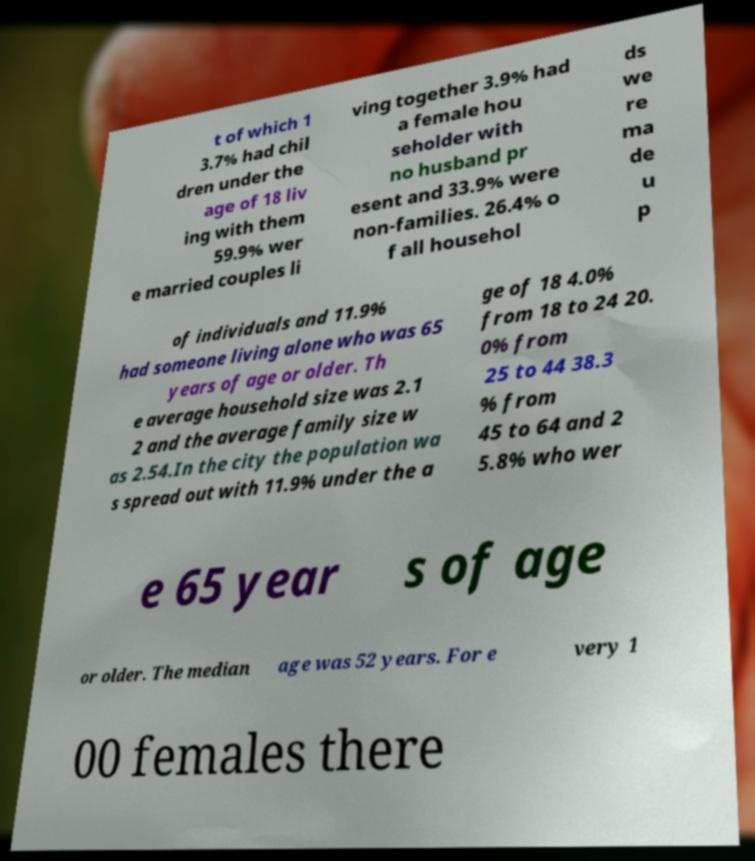Please identify and transcribe the text found in this image. t of which 1 3.7% had chil dren under the age of 18 liv ing with them 59.9% wer e married couples li ving together 3.9% had a female hou seholder with no husband pr esent and 33.9% were non-families. 26.4% o f all househol ds we re ma de u p of individuals and 11.9% had someone living alone who was 65 years of age or older. Th e average household size was 2.1 2 and the average family size w as 2.54.In the city the population wa s spread out with 11.9% under the a ge of 18 4.0% from 18 to 24 20. 0% from 25 to 44 38.3 % from 45 to 64 and 2 5.8% who wer e 65 year s of age or older. The median age was 52 years. For e very 1 00 females there 